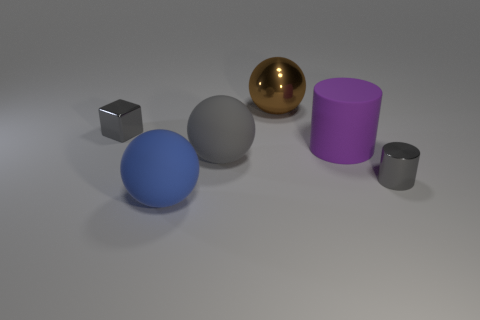There is a matte sphere that is the same color as the tiny cylinder; what is its size?
Your answer should be very brief. Large. Are there any objects in front of the large brown metallic object?
Keep it short and to the point. Yes. Is there a large purple cylinder to the left of the small metal thing that is to the right of the big blue rubber object?
Your answer should be very brief. Yes. Is the number of purple objects on the left side of the gray metallic cube less than the number of objects behind the big purple cylinder?
Your answer should be very brief. Yes. What shape is the large purple object?
Offer a very short reply. Cylinder. There is a cylinder that is left of the shiny cylinder; what material is it?
Provide a short and direct response. Rubber. What is the size of the matte thing in front of the gray shiny object that is in front of the tiny shiny thing on the left side of the large brown metal sphere?
Provide a short and direct response. Large. Does the tiny gray thing that is right of the brown ball have the same material as the large gray sphere to the left of the large brown ball?
Your answer should be compact. No. How many other objects are the same color as the block?
Provide a succinct answer. 2. What number of objects are either objects left of the small shiny cylinder or small gray metal objects that are on the left side of the brown ball?
Ensure brevity in your answer.  5. 